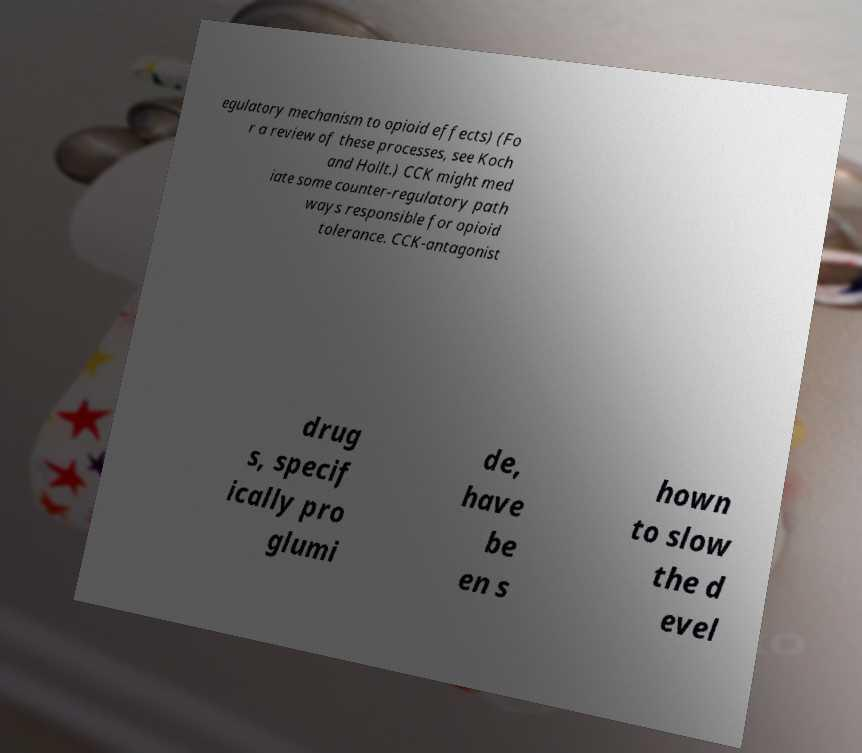Can you accurately transcribe the text from the provided image for me? egulatory mechanism to opioid effects) (Fo r a review of these processes, see Koch and Hollt.) CCK might med iate some counter-regulatory path ways responsible for opioid tolerance. CCK-antagonist drug s, specif ically pro glumi de, have be en s hown to slow the d evel 